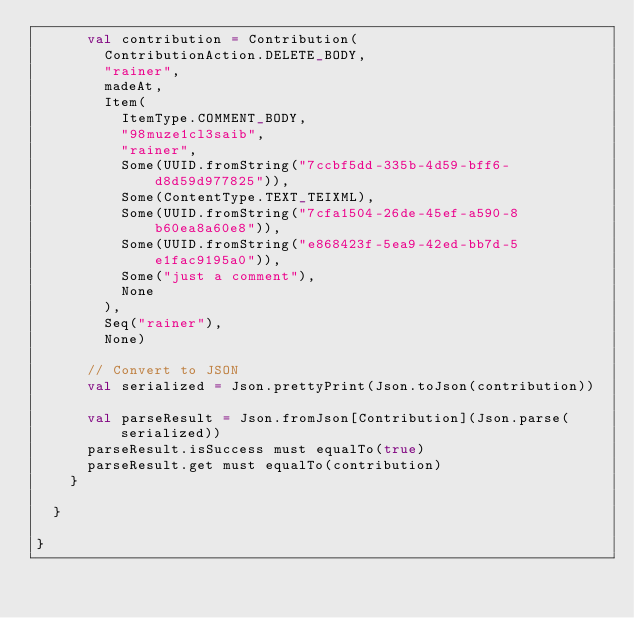<code> <loc_0><loc_0><loc_500><loc_500><_Scala_>      val contribution = Contribution(
        ContributionAction.DELETE_BODY,
        "rainer",
        madeAt,
        Item(
          ItemType.COMMENT_BODY,
          "98muze1cl3saib",
          "rainer",
          Some(UUID.fromString("7ccbf5dd-335b-4d59-bff6-d8d59d977825")),
          Some(ContentType.TEXT_TEIXML),
          Some(UUID.fromString("7cfa1504-26de-45ef-a590-8b60ea8a60e8")),
          Some(UUID.fromString("e868423f-5ea9-42ed-bb7d-5e1fac9195a0")),
          Some("just a comment"),
          None
        ),
        Seq("rainer"),
        None)
        
      // Convert to JSON
      val serialized = Json.prettyPrint(Json.toJson(contribution))
      
      val parseResult = Json.fromJson[Contribution](Json.parse(serialized))
      parseResult.isSuccess must equalTo(true)
      parseResult.get must equalTo(contribution)
    }
    
  }
  
}</code> 